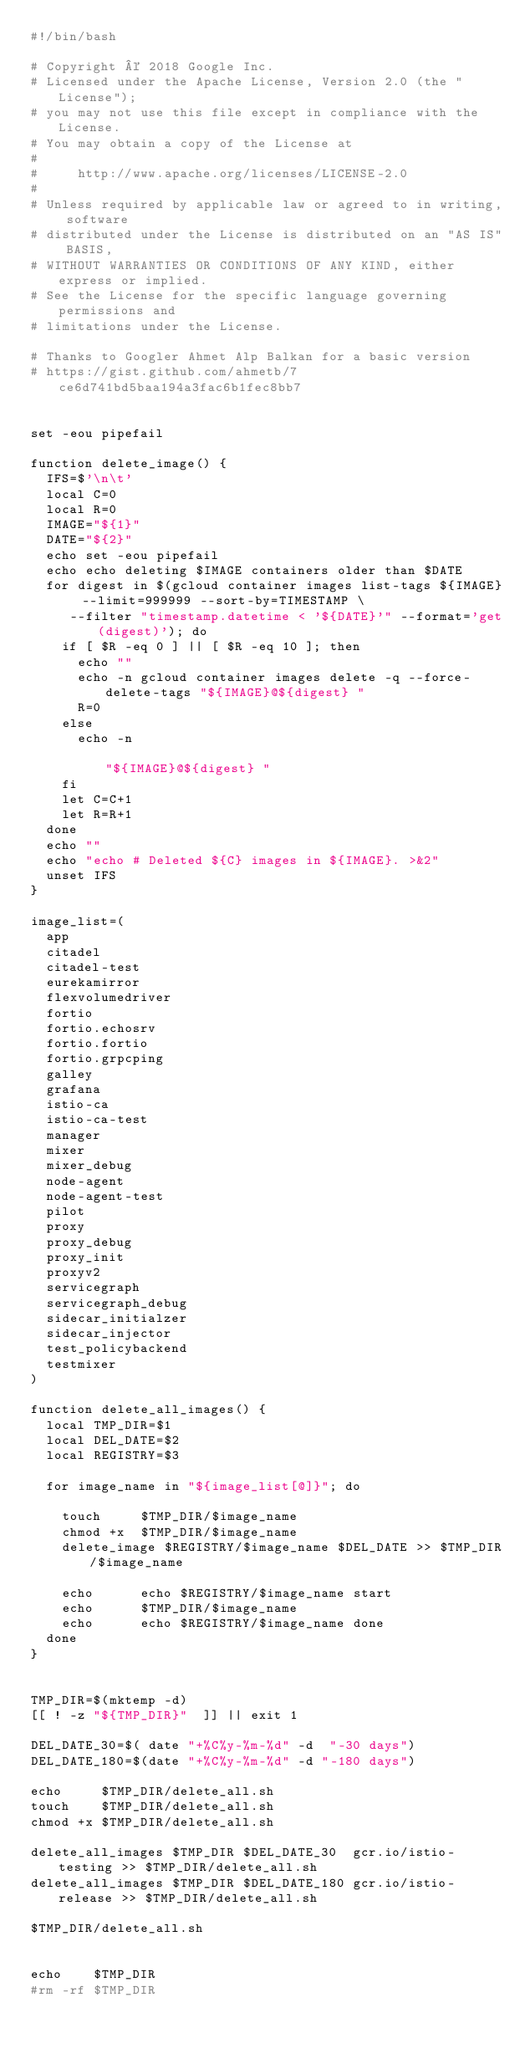<code> <loc_0><loc_0><loc_500><loc_500><_Bash_>#!/bin/bash

# Copyright © 2018 Google Inc.
# Licensed under the Apache License, Version 2.0 (the "License");
# you may not use this file except in compliance with the License.
# You may obtain a copy of the License at
#
#     http://www.apache.org/licenses/LICENSE-2.0
#
# Unless required by applicable law or agreed to in writing, software
# distributed under the License is distributed on an "AS IS" BASIS,
# WITHOUT WARRANTIES OR CONDITIONS OF ANY KIND, either express or implied.
# See the License for the specific language governing permissions and
# limitations under the License.

# Thanks to Googler Ahmet Alp Balkan for a basic version
# https://gist.github.com/ahmetb/7ce6d741bd5baa194a3fac6b1fec8bb7


set -eou pipefail

function delete_image() {
  IFS=$'\n\t'
  local C=0
  local R=0
  IMAGE="${1}"
  DATE="${2}"
  echo set -eou pipefail
  echo echo deleting $IMAGE containers older than $DATE
  for digest in $(gcloud container images list-tags ${IMAGE} --limit=999999 --sort-by=TIMESTAMP \
     --filter "timestamp.datetime < '${DATE}'" --format='get(digest)'); do
    if [ $R -eq 0 ] || [ $R -eq 10 ]; then
      echo ""
      echo -n gcloud container images delete -q --force-delete-tags "${IMAGE}@${digest} "
      R=0
    else
      echo -n                                                       "${IMAGE}@${digest} "
    fi
    let C=C+1
    let R=R+1
  done
  echo ""
  echo "echo # Deleted ${C} images in ${IMAGE}. >&2"
  unset IFS
}

image_list=(
  app
  citadel
  citadel-test
  eurekamirror
  flexvolumedriver
  fortio
  fortio.echosrv
  fortio.fortio
  fortio.grpcping
  galley
  grafana
  istio-ca
  istio-ca-test
  manager
  mixer
  mixer_debug
  node-agent
  node-agent-test
  pilot
  proxy
  proxy_debug
  proxy_init
  proxyv2
  servicegraph
  servicegraph_debug
  sidecar_initialzer
  sidecar_injector
  test_policybackend
  testmixer
)

function delete_all_images() {
  local TMP_DIR=$1
  local DEL_DATE=$2
  local REGISTRY=$3

  for image_name in "${image_list[@]}"; do

    touch     $TMP_DIR/$image_name
    chmod +x  $TMP_DIR/$image_name
    delete_image $REGISTRY/$image_name $DEL_DATE >> $TMP_DIR/$image_name

    echo      echo $REGISTRY/$image_name start
    echo      $TMP_DIR/$image_name
    echo      echo $REGISTRY/$image_name done
  done
}


TMP_DIR=$(mktemp -d)
[[ ! -z "${TMP_DIR}"  ]] || exit 1

DEL_DATE_30=$( date "+%C%y-%m-%d" -d  "-30 days")
DEL_DATE_180=$(date "+%C%y-%m-%d" -d "-180 days")

echo     $TMP_DIR/delete_all.sh
touch    $TMP_DIR/delete_all.sh
chmod +x $TMP_DIR/delete_all.sh

delete_all_images $TMP_DIR $DEL_DATE_30  gcr.io/istio-testing >> $TMP_DIR/delete_all.sh
delete_all_images $TMP_DIR $DEL_DATE_180 gcr.io/istio-release >> $TMP_DIR/delete_all.sh

$TMP_DIR/delete_all.sh


echo    $TMP_DIR
#rm -rf $TMP_DIR
</code> 